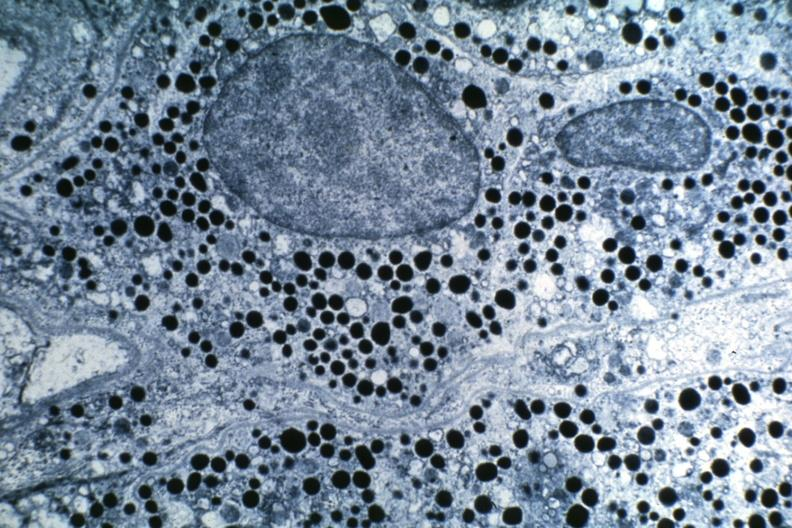what does this image show?
Answer the question using a single word or phrase. Prolactin secreting dr garcia tumors 34 